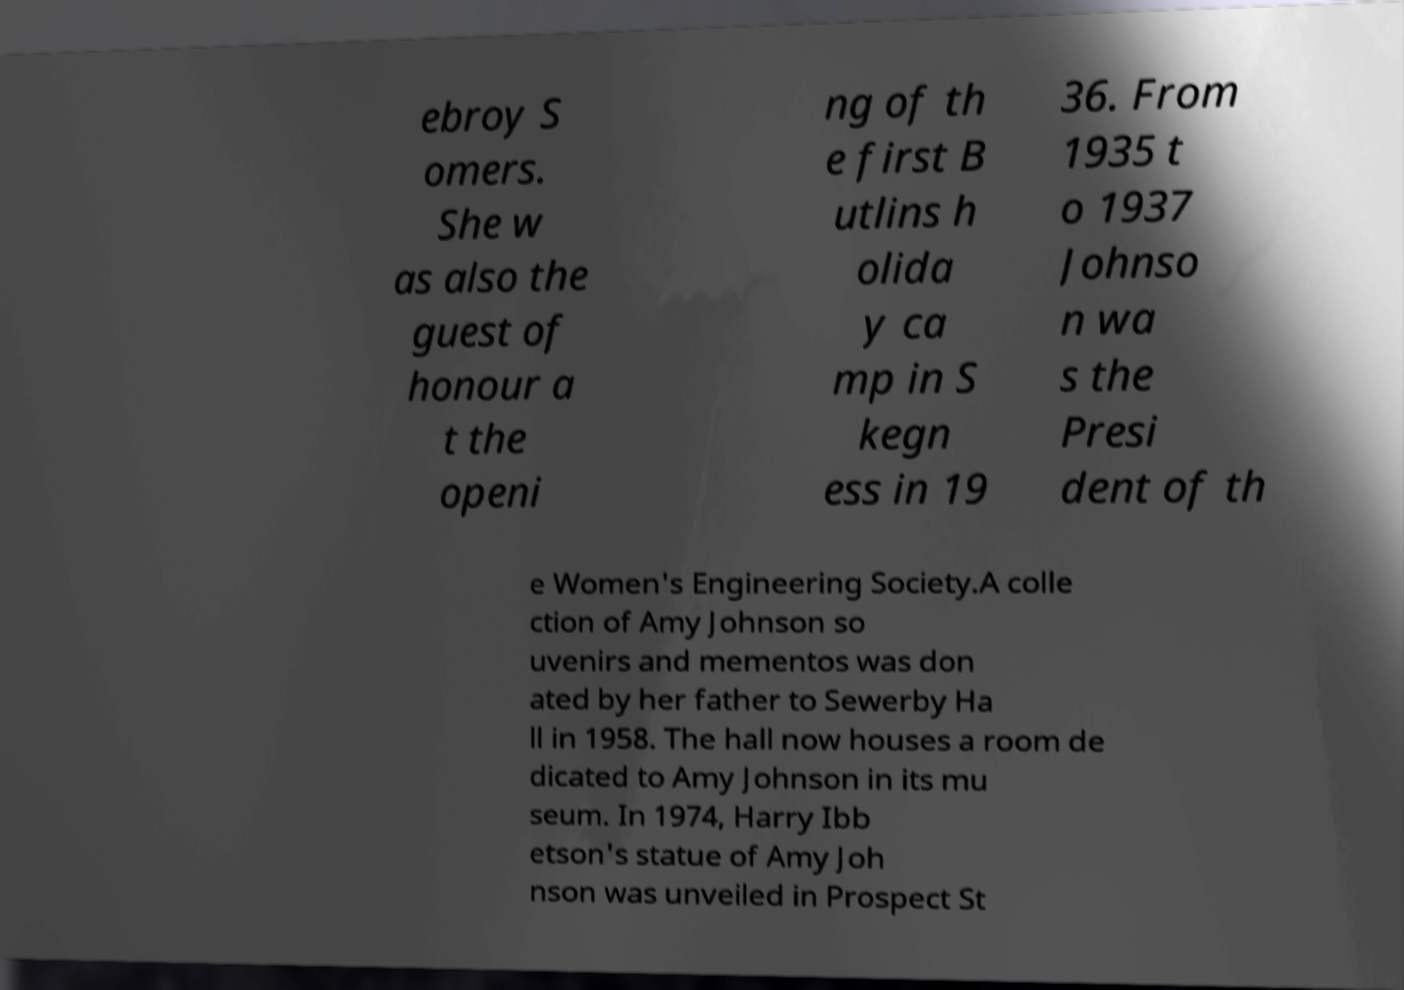What messages or text are displayed in this image? I need them in a readable, typed format. ebroy S omers. She w as also the guest of honour a t the openi ng of th e first B utlins h olida y ca mp in S kegn ess in 19 36. From 1935 t o 1937 Johnso n wa s the Presi dent of th e Women's Engineering Society.A colle ction of Amy Johnson so uvenirs and mementos was don ated by her father to Sewerby Ha ll in 1958. The hall now houses a room de dicated to Amy Johnson in its mu seum. In 1974, Harry Ibb etson's statue of Amy Joh nson was unveiled in Prospect St 